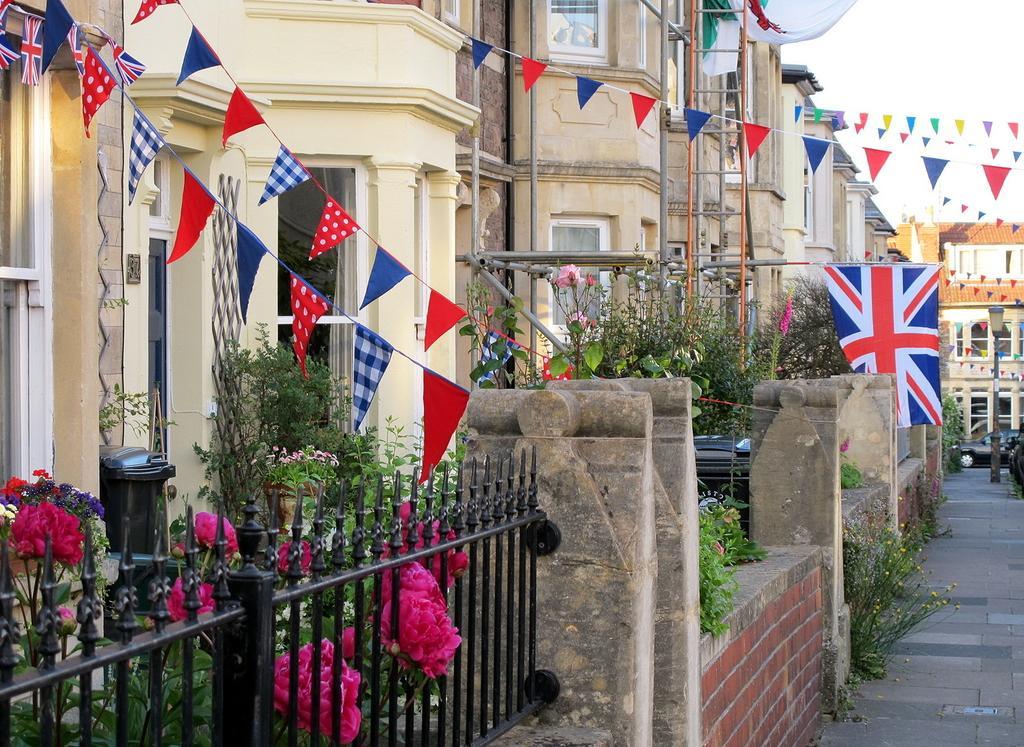Could you give a brief overview of what you see in this image? In this image we can see sky, buildings, street pole, street lights, grill, bins, trees, plants, flowers, grass, decors and road. 